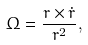Convert formula to latex. <formula><loc_0><loc_0><loc_500><loc_500>\Omega = \frac { r \times { \dot { r } } } { r ^ { 2 } } ,</formula> 